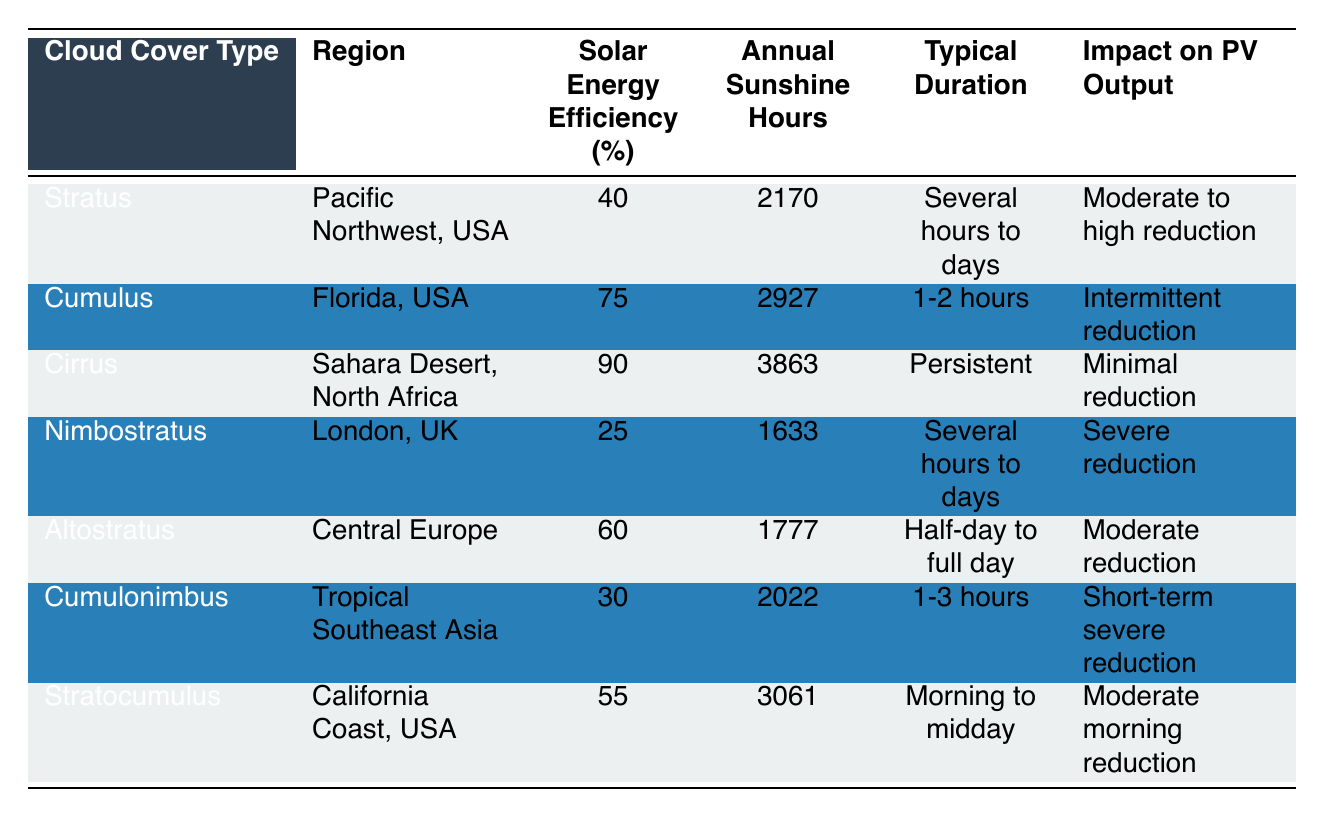What is the Solar Energy Efficiency for Cirrus cloud cover type? The table shows that for the Cirrus cloud cover type, the Solar Energy Efficiency is 90%.
Answer: 90% Which region experiences the lowest Solar Energy Efficiency? By comparing the Solar Energy Efficiency values in the table, Nimbostratus in London, UK has the lowest at 25%.
Answer: 25% What is the total Annual Sunshine Hours for regions with Stratus and Nimbostratus cloud cover types? Adding the Annual Sunshine Hours for Stratus (2170) and Nimbostratus (1633), we get 2170 + 1633 = 3803.
Answer: 3803 Is the Solar Energy Efficiency for Cumulonimbus lower than for Altostratus? In the table, Cumulonimbus has a Solar Energy Efficiency of 30%, while Altostratus has 60%. Therefore, Cumulonimbus is indeed lower.
Answer: Yes How does the impact on PV output of Cirrus compare to that of Cumulonimbus? Cirrus has a "Minimal reduction" impact on PV output, whereas Cumulonimbus is described as having "Short-term severe reduction." Therefore, Cirrus has a significantly less negative impact compared to Cumulonimbus.
Answer: Cirrus has less impact than Cumulonimbus What is the average Solar Energy Efficiency of the cloud cover types listed in the table? To find the average, we add the Solar Energy Efficiency percentages: 40 + 75 + 90 + 25 + 60 + 30 + 55 = 375. There are 7 entries, so 375 / 7 = approximately 53.57, which can be rounded to 54.
Answer: 54 Which cloud cover type has the highest Annual Sunshine Hours, and how many hours is that? Looking at the Annual Sunshine Hours column, Cirrus has the highest value of 3863 hours.
Answer: 3863 What is the typical duration of Cumulus cloud cover? According to the table, the typical duration for Cumulus cloud cover is 1-2 hours.
Answer: 1-2 hours 